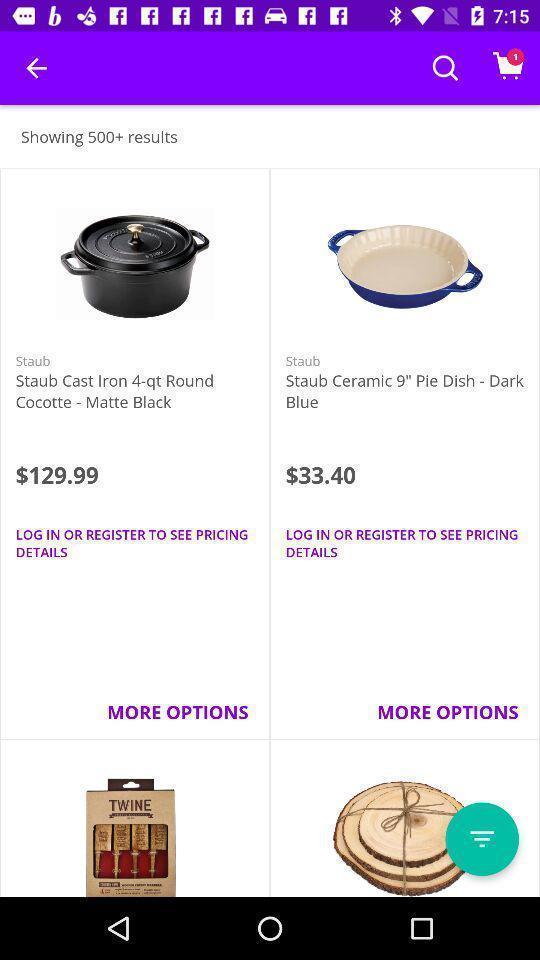Describe the content in this image. Screen shows products for sale in the shopping app. 